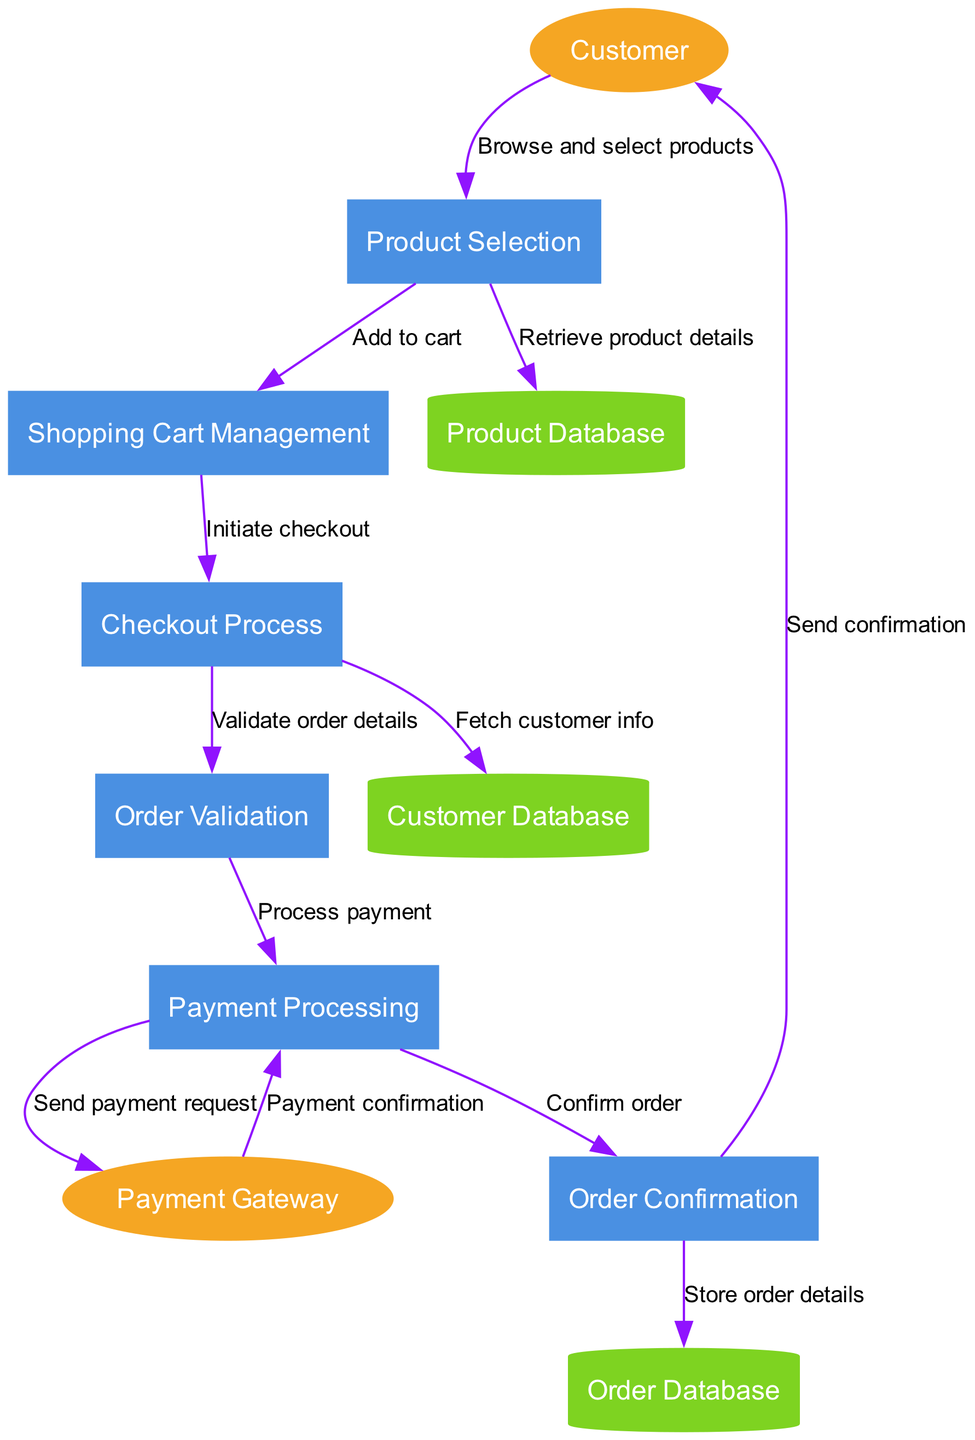What is the first process in the diagram? The first process in the diagram, as indicated by its position, is "Product Selection".
Answer: Product Selection How many external entities are present in the diagram? The diagram shows a total of 2 external entities: "Customer" and "Payment Gateway".
Answer: 2 What data flow connects the "Product Selection" process to the "Product Database"? The connection is labeled "Retrieve product details", illustrating the information flow from the Product Selection process to the Product Database.
Answer: Retrieve product details Which process directly interacts with the "Payment Gateway"? The "Payment Processing" process interacts directly with the "Payment Gateway" as it sends a payment request, indicating the transaction process.
Answer: Payment Processing What is the last process before the customer receives confirmation? The last process before confirmation is "Order Confirmation", where the finalizing actions take place before sending the order details to the customer.
Answer: Order Confirmation Describe the flow of information from "Order Validation" to "Payment Processing". After "Order Validation" checks and validates order details, it flows the information to "Payment Processing" labeled "Process payment", initiating the payment handling.
Answer: Process payment How many data stores are indicated in the diagram? There are 3 data stores highlighted in the diagram: "Product Database", "Customer Database", and "Order Database".
Answer: 3 Which external entity is informed after the "Order Confirmation" process? The "Customer" is the external entity that receives a notification or confirmation after the "Order Confirmation" process completes.
Answer: Customer What is the purpose of the "Checkout Process"? The "Checkout Process" fetches customer information and validates order details, facilitating a smooth transition to payment and order confirmation.
Answer: Fetch customer info and Validate order details What relationship does "Shopping Cart Management" have with the "Checkout Process"? The "Shopping Cart Management" initiates checkout and sends the control flow to the "Checkout Process", indicating the transition in the buying sequence.
Answer: Initiate checkout 